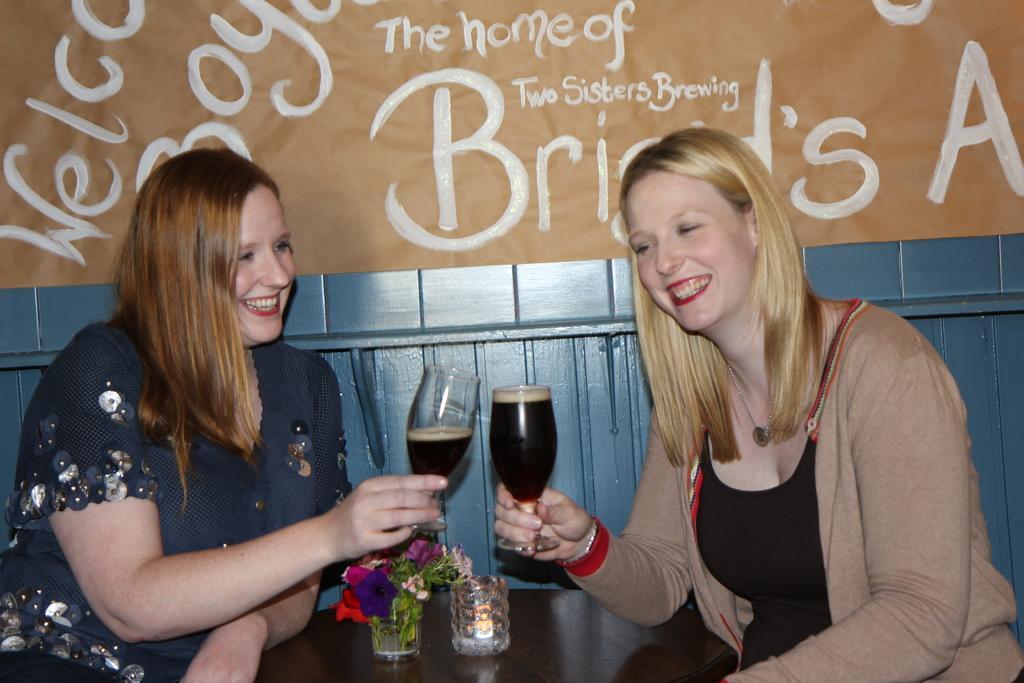In one or two sentences, can you explain what this image depicts? In this picture we can see two ladies on the chair holding bottles in front of the table on which there is a small plant. 